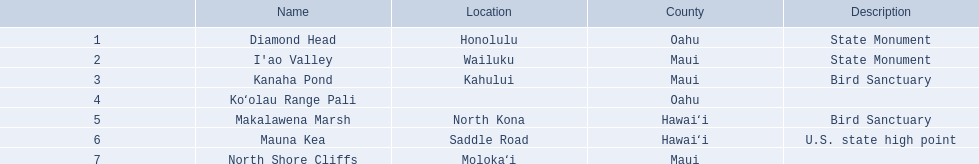What are the different landmark names? Diamond Head, I'ao Valley, Kanaha Pond, Koʻolau Range Pali, Makalawena Marsh, Mauna Kea, North Shore Cliffs. Which of these is located in the county hawai`i? Makalawena Marsh, Mauna Kea. Which of these is not mauna kea? Makalawena Marsh. 